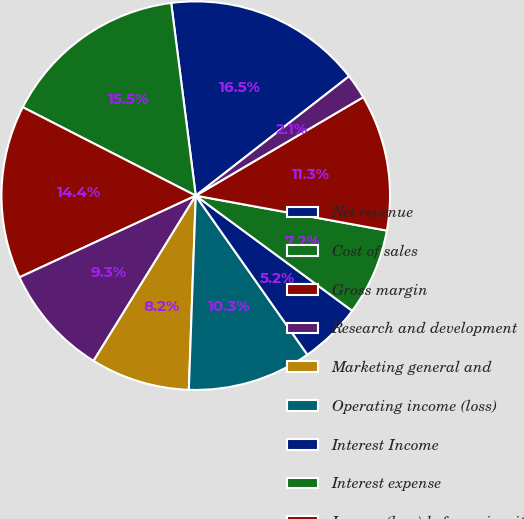Convert chart to OTSL. <chart><loc_0><loc_0><loc_500><loc_500><pie_chart><fcel>Net revenue<fcel>Cost of sales<fcel>Gross margin<fcel>Research and development<fcel>Marketing general and<fcel>Operating income (loss)<fcel>Interest Income<fcel>Interest expense<fcel>Income (loss) before minority<fcel>Minority interest in<nl><fcel>16.49%<fcel>15.46%<fcel>14.43%<fcel>9.28%<fcel>8.25%<fcel>10.31%<fcel>5.16%<fcel>7.22%<fcel>11.34%<fcel>2.07%<nl></chart> 